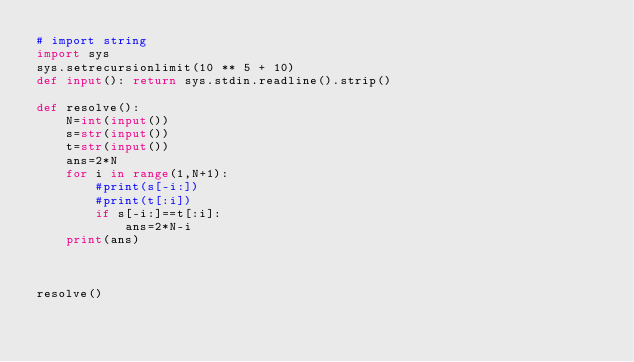<code> <loc_0><loc_0><loc_500><loc_500><_Python_># import string
import sys
sys.setrecursionlimit(10 ** 5 + 10)
def input(): return sys.stdin.readline().strip()

def resolve():
    N=int(input())
    s=str(input())
    t=str(input())
    ans=2*N
    for i in range(1,N+1):
        #print(s[-i:])
        #print(t[:i])
        if s[-i:]==t[:i]:
            ans=2*N-i
    print(ans)



resolve()</code> 